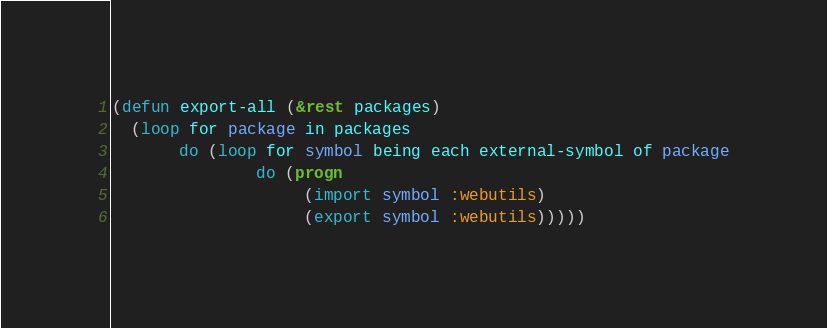Convert code to text. <code><loc_0><loc_0><loc_500><loc_500><_Lisp_>(defun export-all (&rest packages)
  (loop for package in packages
       do (loop for symbol being each external-symbol of package
               do (progn
                    (import symbol :webutils)
                    (export symbol :webutils)))))

</code> 